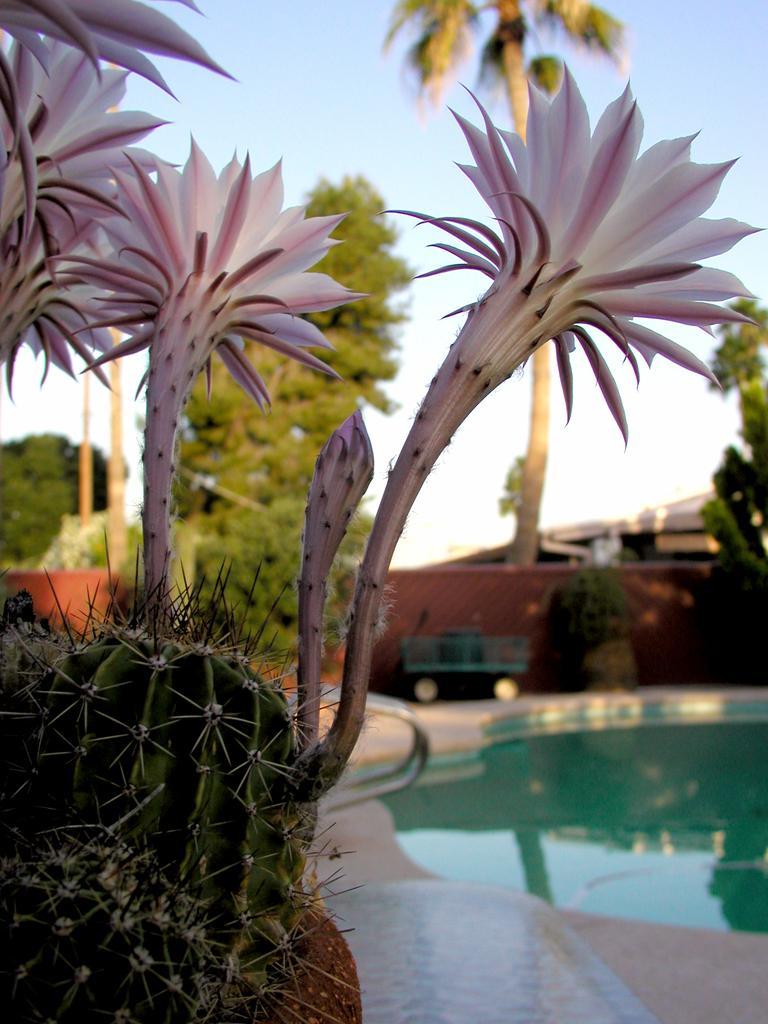In one or two sentences, can you explain what this image depicts? On the left side, there is a plant having flowers which are in pink and white color combination. On the right side, there is a swimming pool. In the background, there is a brown color wall, there are trees, there is a building and there is blue sky. 